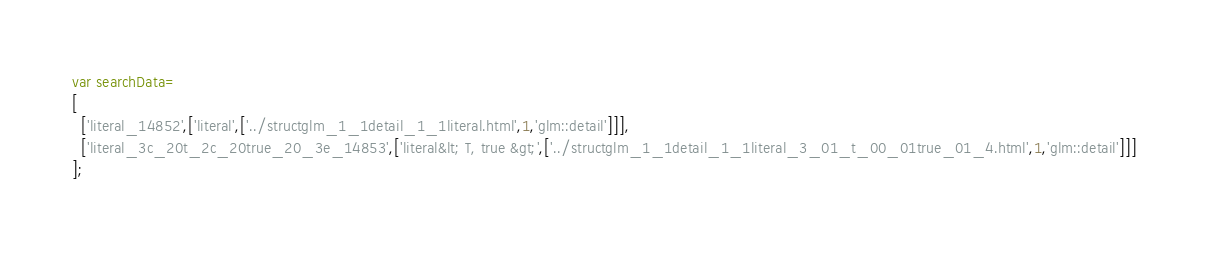Convert code to text. <code><loc_0><loc_0><loc_500><loc_500><_JavaScript_>var searchData=
[
  ['literal_14852',['literal',['../structglm_1_1detail_1_1literal.html',1,'glm::detail']]],
  ['literal_3c_20t_2c_20true_20_3e_14853',['literal&lt; T, true &gt;',['../structglm_1_1detail_1_1literal_3_01_t_00_01true_01_4.html',1,'glm::detail']]]
];
</code> 